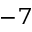<formula> <loc_0><loc_0><loc_500><loc_500>^ { - 7 }</formula> 